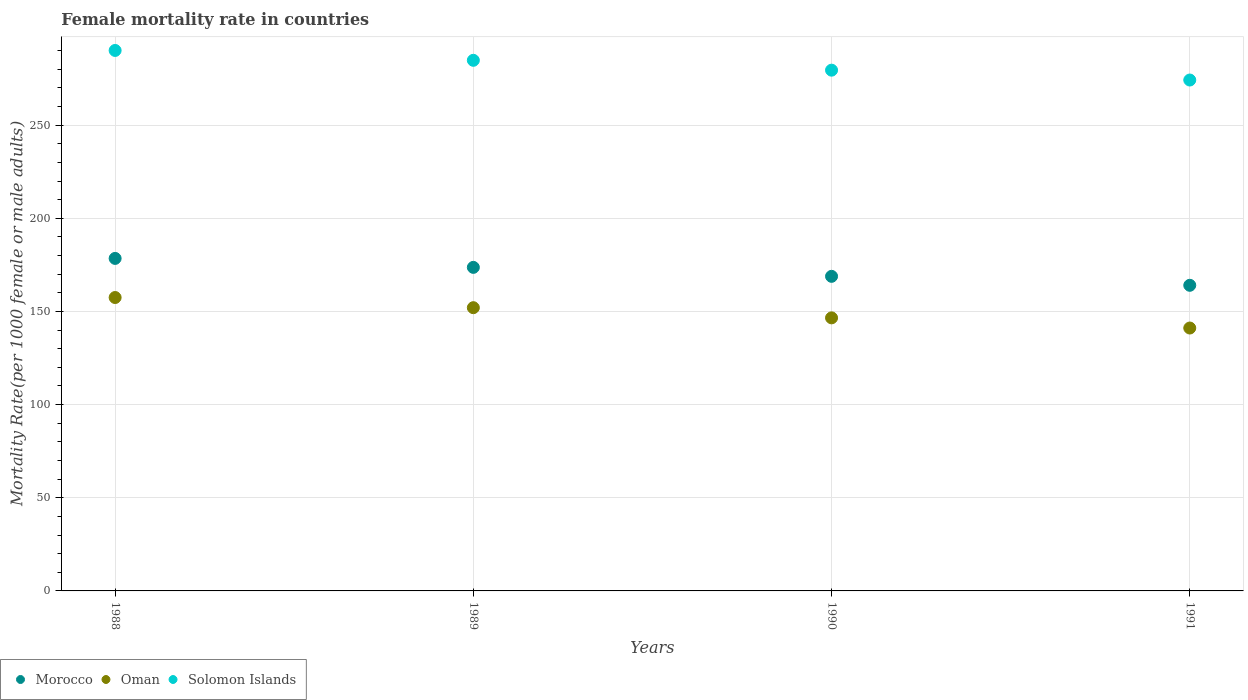What is the female mortality rate in Solomon Islands in 1991?
Make the answer very short. 274.23. Across all years, what is the maximum female mortality rate in Oman?
Offer a terse response. 157.49. Across all years, what is the minimum female mortality rate in Oman?
Ensure brevity in your answer.  141.11. In which year was the female mortality rate in Morocco maximum?
Keep it short and to the point. 1988. In which year was the female mortality rate in Solomon Islands minimum?
Your answer should be compact. 1991. What is the total female mortality rate in Solomon Islands in the graph?
Make the answer very short. 1128.65. What is the difference between the female mortality rate in Morocco in 1988 and that in 1989?
Keep it short and to the point. 4.81. What is the difference between the female mortality rate in Morocco in 1991 and the female mortality rate in Solomon Islands in 1989?
Your answer should be compact. -120.77. What is the average female mortality rate in Morocco per year?
Provide a short and direct response. 171.26. In the year 1988, what is the difference between the female mortality rate in Oman and female mortality rate in Morocco?
Keep it short and to the point. -20.99. In how many years, is the female mortality rate in Oman greater than 10?
Provide a succinct answer. 4. What is the ratio of the female mortality rate in Morocco in 1989 to that in 1991?
Your answer should be very brief. 1.06. Is the female mortality rate in Morocco in 1988 less than that in 1990?
Provide a short and direct response. No. Is the difference between the female mortality rate in Oman in 1988 and 1989 greater than the difference between the female mortality rate in Morocco in 1988 and 1989?
Your answer should be compact. Yes. What is the difference between the highest and the second highest female mortality rate in Solomon Islands?
Provide a succinct answer. 5.29. What is the difference between the highest and the lowest female mortality rate in Solomon Islands?
Give a very brief answer. 15.87. Is the sum of the female mortality rate in Solomon Islands in 1989 and 1991 greater than the maximum female mortality rate in Oman across all years?
Keep it short and to the point. Yes. Is it the case that in every year, the sum of the female mortality rate in Oman and female mortality rate in Morocco  is greater than the female mortality rate in Solomon Islands?
Offer a very short reply. Yes. Does the female mortality rate in Solomon Islands monotonically increase over the years?
Ensure brevity in your answer.  No. Is the female mortality rate in Morocco strictly less than the female mortality rate in Solomon Islands over the years?
Give a very brief answer. Yes. How many years are there in the graph?
Ensure brevity in your answer.  4. Are the values on the major ticks of Y-axis written in scientific E-notation?
Your answer should be very brief. No. Does the graph contain grids?
Your answer should be compact. Yes. How many legend labels are there?
Offer a very short reply. 3. How are the legend labels stacked?
Your response must be concise. Horizontal. What is the title of the graph?
Give a very brief answer. Female mortality rate in countries. Does "Burkina Faso" appear as one of the legend labels in the graph?
Provide a short and direct response. No. What is the label or title of the Y-axis?
Offer a very short reply. Mortality Rate(per 1000 female or male adults). What is the Mortality Rate(per 1000 female or male adults) of Morocco in 1988?
Your answer should be very brief. 178.48. What is the Mortality Rate(per 1000 female or male adults) of Oman in 1988?
Keep it short and to the point. 157.49. What is the Mortality Rate(per 1000 female or male adults) of Solomon Islands in 1988?
Your answer should be very brief. 290.1. What is the Mortality Rate(per 1000 female or male adults) in Morocco in 1989?
Offer a very short reply. 173.67. What is the Mortality Rate(per 1000 female or male adults) of Oman in 1989?
Provide a short and direct response. 152.03. What is the Mortality Rate(per 1000 female or male adults) in Solomon Islands in 1989?
Your answer should be very brief. 284.81. What is the Mortality Rate(per 1000 female or male adults) in Morocco in 1990?
Provide a short and direct response. 168.86. What is the Mortality Rate(per 1000 female or male adults) of Oman in 1990?
Your response must be concise. 146.57. What is the Mortality Rate(per 1000 female or male adults) in Solomon Islands in 1990?
Offer a very short reply. 279.52. What is the Mortality Rate(per 1000 female or male adults) in Morocco in 1991?
Offer a very short reply. 164.04. What is the Mortality Rate(per 1000 female or male adults) of Oman in 1991?
Your answer should be compact. 141.11. What is the Mortality Rate(per 1000 female or male adults) of Solomon Islands in 1991?
Your answer should be compact. 274.23. Across all years, what is the maximum Mortality Rate(per 1000 female or male adults) of Morocco?
Make the answer very short. 178.48. Across all years, what is the maximum Mortality Rate(per 1000 female or male adults) of Oman?
Your answer should be very brief. 157.49. Across all years, what is the maximum Mortality Rate(per 1000 female or male adults) in Solomon Islands?
Offer a very short reply. 290.1. Across all years, what is the minimum Mortality Rate(per 1000 female or male adults) of Morocco?
Keep it short and to the point. 164.04. Across all years, what is the minimum Mortality Rate(per 1000 female or male adults) in Oman?
Your answer should be compact. 141.11. Across all years, what is the minimum Mortality Rate(per 1000 female or male adults) of Solomon Islands?
Give a very brief answer. 274.23. What is the total Mortality Rate(per 1000 female or male adults) in Morocco in the graph?
Your answer should be compact. 685.04. What is the total Mortality Rate(per 1000 female or male adults) of Oman in the graph?
Make the answer very short. 597.19. What is the total Mortality Rate(per 1000 female or male adults) of Solomon Islands in the graph?
Your answer should be compact. 1128.65. What is the difference between the Mortality Rate(per 1000 female or male adults) in Morocco in 1988 and that in 1989?
Your response must be concise. 4.81. What is the difference between the Mortality Rate(per 1000 female or male adults) in Oman in 1988 and that in 1989?
Keep it short and to the point. 5.46. What is the difference between the Mortality Rate(per 1000 female or male adults) in Solomon Islands in 1988 and that in 1989?
Your answer should be very brief. 5.29. What is the difference between the Mortality Rate(per 1000 female or male adults) of Morocco in 1988 and that in 1990?
Your response must be concise. 9.62. What is the difference between the Mortality Rate(per 1000 female or male adults) of Oman in 1988 and that in 1990?
Your response must be concise. 10.92. What is the difference between the Mortality Rate(per 1000 female or male adults) in Solomon Islands in 1988 and that in 1990?
Offer a very short reply. 10.58. What is the difference between the Mortality Rate(per 1000 female or male adults) of Morocco in 1988 and that in 1991?
Make the answer very short. 14.43. What is the difference between the Mortality Rate(per 1000 female or male adults) in Oman in 1988 and that in 1991?
Offer a terse response. 16.38. What is the difference between the Mortality Rate(per 1000 female or male adults) in Solomon Islands in 1988 and that in 1991?
Your answer should be compact. 15.87. What is the difference between the Mortality Rate(per 1000 female or male adults) in Morocco in 1989 and that in 1990?
Offer a very short reply. 4.81. What is the difference between the Mortality Rate(per 1000 female or male adults) of Oman in 1989 and that in 1990?
Your answer should be very brief. 5.46. What is the difference between the Mortality Rate(per 1000 female or male adults) of Solomon Islands in 1989 and that in 1990?
Provide a succinct answer. 5.29. What is the difference between the Mortality Rate(per 1000 female or male adults) of Morocco in 1989 and that in 1991?
Provide a short and direct response. 9.62. What is the difference between the Mortality Rate(per 1000 female or male adults) in Oman in 1989 and that in 1991?
Your answer should be very brief. 10.92. What is the difference between the Mortality Rate(per 1000 female or male adults) in Solomon Islands in 1989 and that in 1991?
Provide a succinct answer. 10.58. What is the difference between the Mortality Rate(per 1000 female or male adults) in Morocco in 1990 and that in 1991?
Your response must be concise. 4.81. What is the difference between the Mortality Rate(per 1000 female or male adults) of Oman in 1990 and that in 1991?
Make the answer very short. 5.46. What is the difference between the Mortality Rate(per 1000 female or male adults) of Solomon Islands in 1990 and that in 1991?
Your answer should be very brief. 5.29. What is the difference between the Mortality Rate(per 1000 female or male adults) of Morocco in 1988 and the Mortality Rate(per 1000 female or male adults) of Oman in 1989?
Your answer should be compact. 26.45. What is the difference between the Mortality Rate(per 1000 female or male adults) in Morocco in 1988 and the Mortality Rate(per 1000 female or male adults) in Solomon Islands in 1989?
Keep it short and to the point. -106.33. What is the difference between the Mortality Rate(per 1000 female or male adults) of Oman in 1988 and the Mortality Rate(per 1000 female or male adults) of Solomon Islands in 1989?
Make the answer very short. -127.32. What is the difference between the Mortality Rate(per 1000 female or male adults) in Morocco in 1988 and the Mortality Rate(per 1000 female or male adults) in Oman in 1990?
Offer a terse response. 31.91. What is the difference between the Mortality Rate(per 1000 female or male adults) of Morocco in 1988 and the Mortality Rate(per 1000 female or male adults) of Solomon Islands in 1990?
Keep it short and to the point. -101.04. What is the difference between the Mortality Rate(per 1000 female or male adults) of Oman in 1988 and the Mortality Rate(per 1000 female or male adults) of Solomon Islands in 1990?
Your response must be concise. -122.03. What is the difference between the Mortality Rate(per 1000 female or male adults) of Morocco in 1988 and the Mortality Rate(per 1000 female or male adults) of Oman in 1991?
Make the answer very short. 37.37. What is the difference between the Mortality Rate(per 1000 female or male adults) of Morocco in 1988 and the Mortality Rate(per 1000 female or male adults) of Solomon Islands in 1991?
Provide a short and direct response. -95.75. What is the difference between the Mortality Rate(per 1000 female or male adults) of Oman in 1988 and the Mortality Rate(per 1000 female or male adults) of Solomon Islands in 1991?
Your answer should be very brief. -116.74. What is the difference between the Mortality Rate(per 1000 female or male adults) of Morocco in 1989 and the Mortality Rate(per 1000 female or male adults) of Oman in 1990?
Ensure brevity in your answer.  27.1. What is the difference between the Mortality Rate(per 1000 female or male adults) of Morocco in 1989 and the Mortality Rate(per 1000 female or male adults) of Solomon Islands in 1990?
Your answer should be very brief. -105.85. What is the difference between the Mortality Rate(per 1000 female or male adults) of Oman in 1989 and the Mortality Rate(per 1000 female or male adults) of Solomon Islands in 1990?
Your answer should be compact. -127.49. What is the difference between the Mortality Rate(per 1000 female or male adults) in Morocco in 1989 and the Mortality Rate(per 1000 female or male adults) in Oman in 1991?
Your response must be concise. 32.56. What is the difference between the Mortality Rate(per 1000 female or male adults) in Morocco in 1989 and the Mortality Rate(per 1000 female or male adults) in Solomon Islands in 1991?
Provide a short and direct response. -100.56. What is the difference between the Mortality Rate(per 1000 female or male adults) of Oman in 1989 and the Mortality Rate(per 1000 female or male adults) of Solomon Islands in 1991?
Your answer should be very brief. -122.2. What is the difference between the Mortality Rate(per 1000 female or male adults) in Morocco in 1990 and the Mortality Rate(per 1000 female or male adults) in Oman in 1991?
Your answer should be very brief. 27.75. What is the difference between the Mortality Rate(per 1000 female or male adults) in Morocco in 1990 and the Mortality Rate(per 1000 female or male adults) in Solomon Islands in 1991?
Keep it short and to the point. -105.37. What is the difference between the Mortality Rate(per 1000 female or male adults) of Oman in 1990 and the Mortality Rate(per 1000 female or male adults) of Solomon Islands in 1991?
Ensure brevity in your answer.  -127.66. What is the average Mortality Rate(per 1000 female or male adults) of Morocco per year?
Offer a very short reply. 171.26. What is the average Mortality Rate(per 1000 female or male adults) in Oman per year?
Offer a very short reply. 149.3. What is the average Mortality Rate(per 1000 female or male adults) in Solomon Islands per year?
Your answer should be very brief. 282.16. In the year 1988, what is the difference between the Mortality Rate(per 1000 female or male adults) in Morocco and Mortality Rate(per 1000 female or male adults) in Oman?
Give a very brief answer. 20.99. In the year 1988, what is the difference between the Mortality Rate(per 1000 female or male adults) in Morocco and Mortality Rate(per 1000 female or male adults) in Solomon Islands?
Offer a terse response. -111.62. In the year 1988, what is the difference between the Mortality Rate(per 1000 female or male adults) of Oman and Mortality Rate(per 1000 female or male adults) of Solomon Islands?
Ensure brevity in your answer.  -132.61. In the year 1989, what is the difference between the Mortality Rate(per 1000 female or male adults) of Morocco and Mortality Rate(per 1000 female or male adults) of Oman?
Your answer should be compact. 21.64. In the year 1989, what is the difference between the Mortality Rate(per 1000 female or male adults) of Morocco and Mortality Rate(per 1000 female or male adults) of Solomon Islands?
Your answer should be compact. -111.14. In the year 1989, what is the difference between the Mortality Rate(per 1000 female or male adults) in Oman and Mortality Rate(per 1000 female or male adults) in Solomon Islands?
Your response must be concise. -132.78. In the year 1990, what is the difference between the Mortality Rate(per 1000 female or male adults) of Morocco and Mortality Rate(per 1000 female or male adults) of Oman?
Offer a terse response. 22.29. In the year 1990, what is the difference between the Mortality Rate(per 1000 female or male adults) of Morocco and Mortality Rate(per 1000 female or male adults) of Solomon Islands?
Provide a short and direct response. -110.66. In the year 1990, what is the difference between the Mortality Rate(per 1000 female or male adults) in Oman and Mortality Rate(per 1000 female or male adults) in Solomon Islands?
Your answer should be very brief. -132.95. In the year 1991, what is the difference between the Mortality Rate(per 1000 female or male adults) in Morocco and Mortality Rate(per 1000 female or male adults) in Oman?
Your response must be concise. 22.93. In the year 1991, what is the difference between the Mortality Rate(per 1000 female or male adults) in Morocco and Mortality Rate(per 1000 female or male adults) in Solomon Islands?
Give a very brief answer. -110.18. In the year 1991, what is the difference between the Mortality Rate(per 1000 female or male adults) of Oman and Mortality Rate(per 1000 female or male adults) of Solomon Islands?
Keep it short and to the point. -133.12. What is the ratio of the Mortality Rate(per 1000 female or male adults) in Morocco in 1988 to that in 1989?
Offer a very short reply. 1.03. What is the ratio of the Mortality Rate(per 1000 female or male adults) in Oman in 1988 to that in 1989?
Your answer should be compact. 1.04. What is the ratio of the Mortality Rate(per 1000 female or male adults) in Solomon Islands in 1988 to that in 1989?
Give a very brief answer. 1.02. What is the ratio of the Mortality Rate(per 1000 female or male adults) in Morocco in 1988 to that in 1990?
Provide a succinct answer. 1.06. What is the ratio of the Mortality Rate(per 1000 female or male adults) of Oman in 1988 to that in 1990?
Your answer should be compact. 1.07. What is the ratio of the Mortality Rate(per 1000 female or male adults) of Solomon Islands in 1988 to that in 1990?
Your answer should be compact. 1.04. What is the ratio of the Mortality Rate(per 1000 female or male adults) of Morocco in 1988 to that in 1991?
Your answer should be compact. 1.09. What is the ratio of the Mortality Rate(per 1000 female or male adults) in Oman in 1988 to that in 1991?
Your response must be concise. 1.12. What is the ratio of the Mortality Rate(per 1000 female or male adults) in Solomon Islands in 1988 to that in 1991?
Provide a succinct answer. 1.06. What is the ratio of the Mortality Rate(per 1000 female or male adults) of Morocco in 1989 to that in 1990?
Your answer should be compact. 1.03. What is the ratio of the Mortality Rate(per 1000 female or male adults) in Oman in 1989 to that in 1990?
Ensure brevity in your answer.  1.04. What is the ratio of the Mortality Rate(per 1000 female or male adults) of Solomon Islands in 1989 to that in 1990?
Offer a very short reply. 1.02. What is the ratio of the Mortality Rate(per 1000 female or male adults) in Morocco in 1989 to that in 1991?
Keep it short and to the point. 1.06. What is the ratio of the Mortality Rate(per 1000 female or male adults) of Oman in 1989 to that in 1991?
Your response must be concise. 1.08. What is the ratio of the Mortality Rate(per 1000 female or male adults) in Solomon Islands in 1989 to that in 1991?
Provide a succinct answer. 1.04. What is the ratio of the Mortality Rate(per 1000 female or male adults) in Morocco in 1990 to that in 1991?
Your answer should be compact. 1.03. What is the ratio of the Mortality Rate(per 1000 female or male adults) of Oman in 1990 to that in 1991?
Ensure brevity in your answer.  1.04. What is the ratio of the Mortality Rate(per 1000 female or male adults) of Solomon Islands in 1990 to that in 1991?
Your answer should be compact. 1.02. What is the difference between the highest and the second highest Mortality Rate(per 1000 female or male adults) of Morocco?
Keep it short and to the point. 4.81. What is the difference between the highest and the second highest Mortality Rate(per 1000 female or male adults) in Oman?
Ensure brevity in your answer.  5.46. What is the difference between the highest and the second highest Mortality Rate(per 1000 female or male adults) in Solomon Islands?
Ensure brevity in your answer.  5.29. What is the difference between the highest and the lowest Mortality Rate(per 1000 female or male adults) in Morocco?
Provide a succinct answer. 14.43. What is the difference between the highest and the lowest Mortality Rate(per 1000 female or male adults) in Oman?
Your answer should be very brief. 16.38. What is the difference between the highest and the lowest Mortality Rate(per 1000 female or male adults) of Solomon Islands?
Your answer should be very brief. 15.87. 